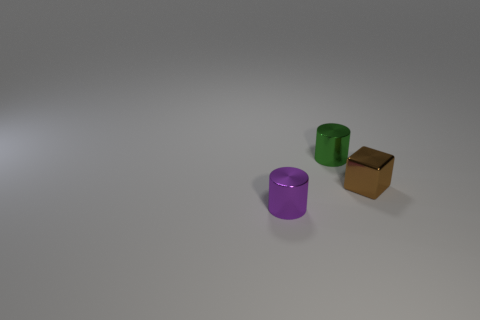Add 2 shiny cubes. How many objects exist? 5 Subtract all cylinders. How many objects are left? 1 Subtract all large gray metal cylinders. Subtract all green shiny cylinders. How many objects are left? 2 Add 3 tiny brown things. How many tiny brown things are left? 4 Add 3 cylinders. How many cylinders exist? 5 Subtract 0 red cylinders. How many objects are left? 3 